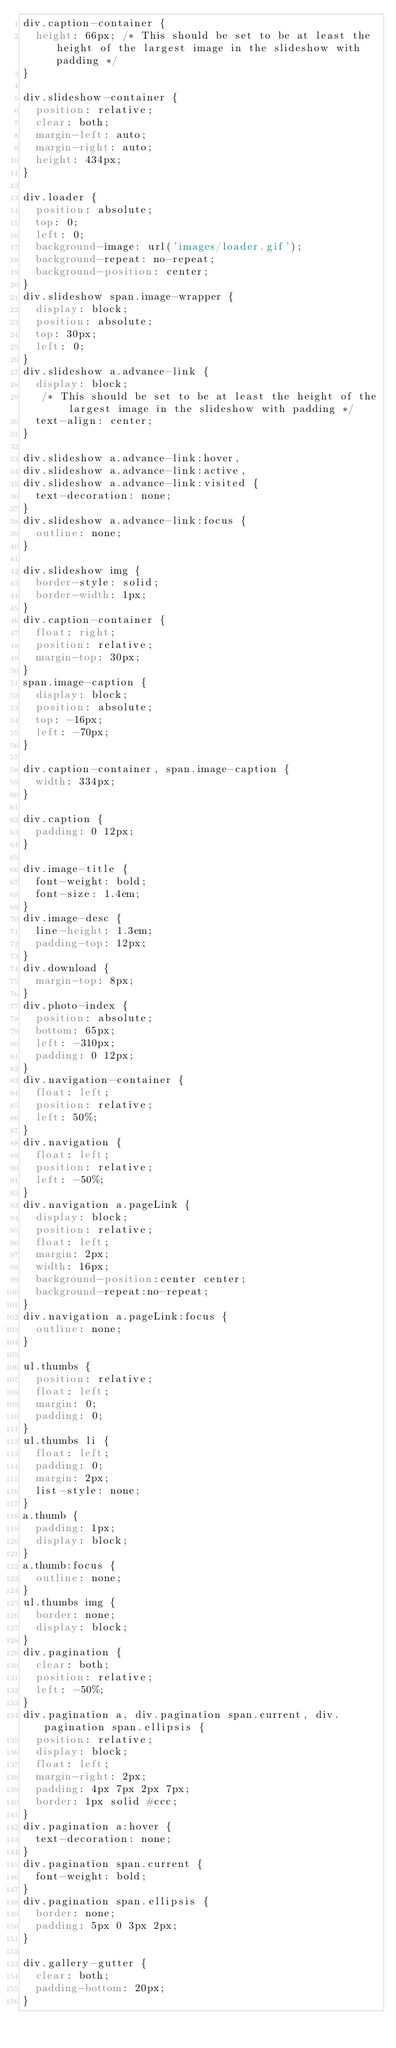<code> <loc_0><loc_0><loc_500><loc_500><_CSS_>div.caption-container {
	height: 66px; /* This should be set to be at least the height of the largest image in the slideshow with padding */	
}

div.slideshow-container {
	position: relative;
	clear: both;
	margin-left: auto;
	margin-right: auto;
	height: 434px;
}

div.loader {
	position: absolute;
	top: 0;
	left: 0;
	background-image: url('images/loader.gif');
	background-repeat: no-repeat;
	background-position: center;
}
div.slideshow span.image-wrapper {
	display: block;
	position: absolute;
	top: 30px;
	left: 0;
}
div.slideshow a.advance-link {
	display: block;
	 /* This should be set to be at least the height of the largest image in the slideshow with padding */
	text-align: center;
}

div.slideshow a.advance-link:hover,
div.slideshow a.advance-link:active,
div.slideshow a.advance-link:visited {
	text-decoration: none;
}
div.slideshow a.advance-link:focus {
	outline: none;
}

div.slideshow img {
	border-style: solid;
	border-width: 1px;
}
div.caption-container {
	float: right;
	position: relative;
	margin-top: 30px;
}
span.image-caption {
	display: block;
	position: absolute;
	top: -16px;
	left: -70px;
}

div.caption-container, span.image-caption {
	width: 334px;
}

div.caption {
	padding: 0 12px;
}

div.image-title {
	font-weight: bold;
	font-size: 1.4em;
}
div.image-desc {
	line-height: 1.3em;
	padding-top: 12px;
}
div.download {
	margin-top: 8px;
}
div.photo-index {
	position: absolute;
	bottom: 65px;
	left: -310px;
	padding: 0 12px;
}
div.navigation-container {
	float: left;
	position: relative;
	left: 50%;
}
div.navigation {
	float: left;
	position: relative;
	left: -50%;
}
div.navigation a.pageLink {
	display: block;
	position: relative;
	float: left;
	margin: 2px;
	width: 16px;
	background-position:center center;
	background-repeat:no-repeat;
}
div.navigation a.pageLink:focus {
	outline: none;
}

ul.thumbs {
	position: relative;
	float: left;
	margin: 0;
	padding: 0;
}
ul.thumbs li {
	float: left;
	padding: 0;
	margin: 2px;
	list-style: none;
}
a.thumb {
	padding: 1px;
	display: block;
}
a.thumb:focus {
	outline: none;
}
ul.thumbs img {
	border: none;
	display: block;
}
div.pagination {
	clear: both;
	position: relative;
	left: -50%;
}
div.pagination a, div.pagination span.current, div.pagination span.ellipsis {
	position: relative;
	display: block;
	float: left;
	margin-right: 2px;
	padding: 4px 7px 2px 7px;
	border: 1px solid #ccc;
}
div.pagination a:hover {
	text-decoration: none;
}
div.pagination span.current {
	font-weight: bold;
}
div.pagination span.ellipsis {
	border: none;
	padding: 5px 0 3px 2px;
}

div.gallery-gutter {
	clear: both;
	padding-bottom: 20px;
}
</code> 